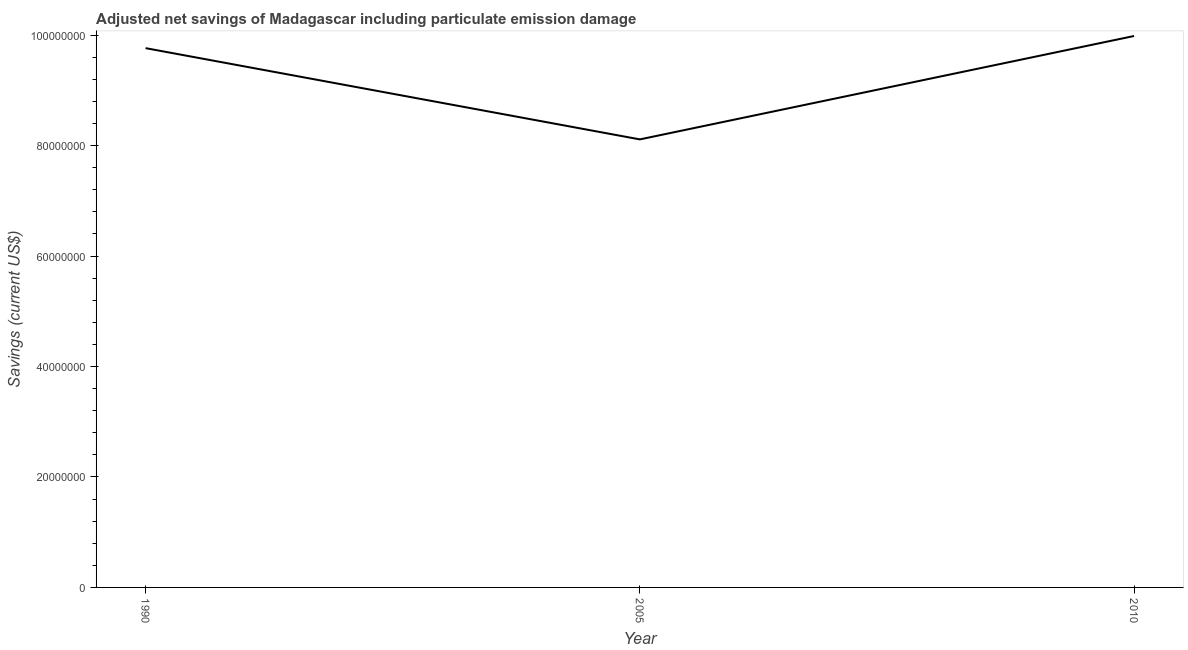What is the adjusted net savings in 2010?
Make the answer very short. 9.98e+07. Across all years, what is the maximum adjusted net savings?
Offer a very short reply. 9.98e+07. Across all years, what is the minimum adjusted net savings?
Give a very brief answer. 8.11e+07. In which year was the adjusted net savings minimum?
Keep it short and to the point. 2005. What is the sum of the adjusted net savings?
Give a very brief answer. 2.79e+08. What is the difference between the adjusted net savings in 1990 and 2010?
Provide a succinct answer. -2.20e+06. What is the average adjusted net savings per year?
Provide a short and direct response. 9.29e+07. What is the median adjusted net savings?
Keep it short and to the point. 9.76e+07. What is the ratio of the adjusted net savings in 2005 to that in 2010?
Provide a short and direct response. 0.81. Is the adjusted net savings in 1990 less than that in 2005?
Offer a very short reply. No. Is the difference between the adjusted net savings in 2005 and 2010 greater than the difference between any two years?
Ensure brevity in your answer.  Yes. What is the difference between the highest and the second highest adjusted net savings?
Offer a terse response. 2.20e+06. What is the difference between the highest and the lowest adjusted net savings?
Provide a succinct answer. 1.87e+07. How many lines are there?
Make the answer very short. 1. How many years are there in the graph?
Make the answer very short. 3. What is the difference between two consecutive major ticks on the Y-axis?
Your response must be concise. 2.00e+07. Are the values on the major ticks of Y-axis written in scientific E-notation?
Provide a short and direct response. No. Does the graph contain any zero values?
Offer a terse response. No. Does the graph contain grids?
Your answer should be very brief. No. What is the title of the graph?
Offer a terse response. Adjusted net savings of Madagascar including particulate emission damage. What is the label or title of the Y-axis?
Give a very brief answer. Savings (current US$). What is the Savings (current US$) in 1990?
Keep it short and to the point. 9.76e+07. What is the Savings (current US$) of 2005?
Provide a succinct answer. 8.11e+07. What is the Savings (current US$) in 2010?
Give a very brief answer. 9.98e+07. What is the difference between the Savings (current US$) in 1990 and 2005?
Give a very brief answer. 1.65e+07. What is the difference between the Savings (current US$) in 1990 and 2010?
Offer a very short reply. -2.20e+06. What is the difference between the Savings (current US$) in 2005 and 2010?
Keep it short and to the point. -1.87e+07. What is the ratio of the Savings (current US$) in 1990 to that in 2005?
Offer a terse response. 1.2. What is the ratio of the Savings (current US$) in 1990 to that in 2010?
Your answer should be very brief. 0.98. What is the ratio of the Savings (current US$) in 2005 to that in 2010?
Make the answer very short. 0.81. 